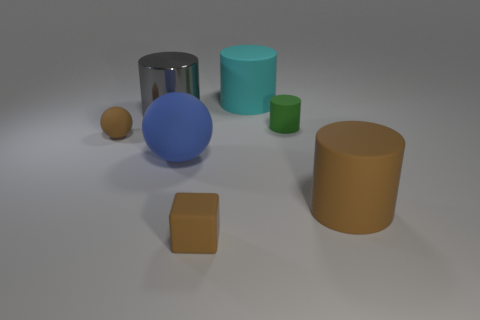Subtract all tiny green rubber cylinders. How many cylinders are left? 3 Add 1 small green matte cylinders. How many objects exist? 8 Subtract all blue spheres. How many spheres are left? 1 Subtract all spheres. How many objects are left? 5 Subtract all cyan spheres. How many brown cylinders are left? 1 Add 4 big rubber objects. How many big rubber objects are left? 7 Add 5 cylinders. How many cylinders exist? 9 Subtract 0 gray blocks. How many objects are left? 7 Subtract 3 cylinders. How many cylinders are left? 1 Subtract all red spheres. Subtract all yellow blocks. How many spheres are left? 2 